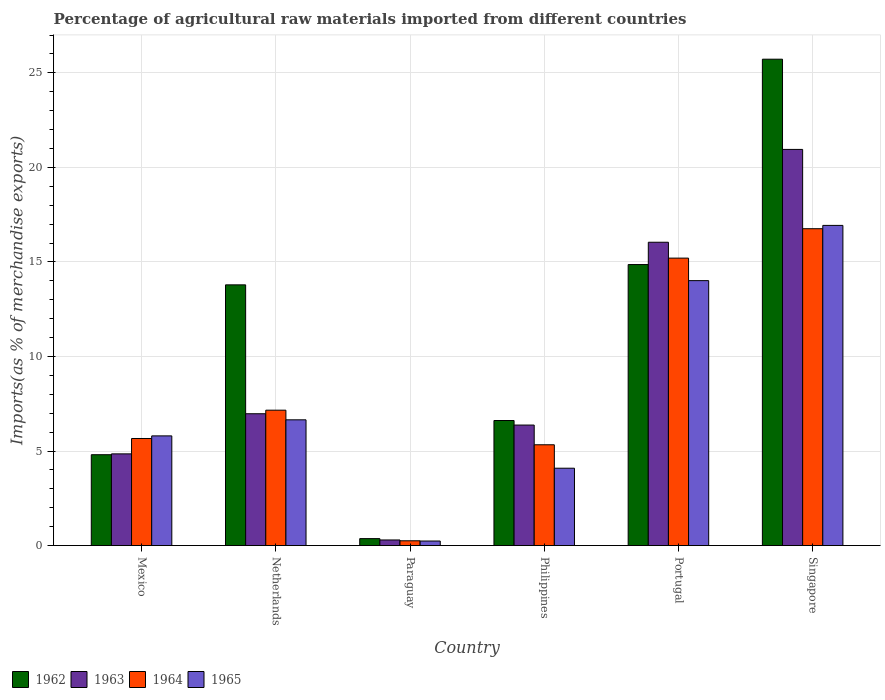How many groups of bars are there?
Make the answer very short. 6. Are the number of bars per tick equal to the number of legend labels?
Offer a terse response. Yes. Are the number of bars on each tick of the X-axis equal?
Your response must be concise. Yes. In how many cases, is the number of bars for a given country not equal to the number of legend labels?
Keep it short and to the point. 0. What is the percentage of imports to different countries in 1962 in Netherlands?
Give a very brief answer. 13.79. Across all countries, what is the maximum percentage of imports to different countries in 1965?
Make the answer very short. 16.93. Across all countries, what is the minimum percentage of imports to different countries in 1962?
Provide a short and direct response. 0.37. In which country was the percentage of imports to different countries in 1963 maximum?
Make the answer very short. Singapore. In which country was the percentage of imports to different countries in 1962 minimum?
Provide a short and direct response. Paraguay. What is the total percentage of imports to different countries in 1963 in the graph?
Your answer should be very brief. 55.49. What is the difference between the percentage of imports to different countries in 1964 in Philippines and that in Portugal?
Your answer should be compact. -9.87. What is the difference between the percentage of imports to different countries in 1963 in Netherlands and the percentage of imports to different countries in 1964 in Paraguay?
Offer a terse response. 6.72. What is the average percentage of imports to different countries in 1964 per country?
Your answer should be very brief. 8.4. What is the difference between the percentage of imports to different countries of/in 1962 and percentage of imports to different countries of/in 1963 in Portugal?
Give a very brief answer. -1.18. What is the ratio of the percentage of imports to different countries in 1963 in Netherlands to that in Philippines?
Your answer should be compact. 1.09. Is the percentage of imports to different countries in 1965 in Netherlands less than that in Paraguay?
Keep it short and to the point. No. Is the difference between the percentage of imports to different countries in 1962 in Netherlands and Paraguay greater than the difference between the percentage of imports to different countries in 1963 in Netherlands and Paraguay?
Your answer should be very brief. Yes. What is the difference between the highest and the second highest percentage of imports to different countries in 1964?
Make the answer very short. 9.6. What is the difference between the highest and the lowest percentage of imports to different countries in 1965?
Offer a very short reply. 16.69. Is the sum of the percentage of imports to different countries in 1962 in Mexico and Philippines greater than the maximum percentage of imports to different countries in 1964 across all countries?
Make the answer very short. No. What does the 3rd bar from the left in Paraguay represents?
Offer a terse response. 1964. Is it the case that in every country, the sum of the percentage of imports to different countries in 1963 and percentage of imports to different countries in 1964 is greater than the percentage of imports to different countries in 1965?
Keep it short and to the point. Yes. How many bars are there?
Make the answer very short. 24. Are all the bars in the graph horizontal?
Provide a succinct answer. No. Does the graph contain grids?
Your answer should be very brief. Yes. How many legend labels are there?
Provide a succinct answer. 4. What is the title of the graph?
Keep it short and to the point. Percentage of agricultural raw materials imported from different countries. Does "1991" appear as one of the legend labels in the graph?
Give a very brief answer. No. What is the label or title of the X-axis?
Ensure brevity in your answer.  Country. What is the label or title of the Y-axis?
Your answer should be compact. Imports(as % of merchandise exports). What is the Imports(as % of merchandise exports) in 1962 in Mexico?
Ensure brevity in your answer.  4.81. What is the Imports(as % of merchandise exports) in 1963 in Mexico?
Make the answer very short. 4.85. What is the Imports(as % of merchandise exports) of 1964 in Mexico?
Give a very brief answer. 5.66. What is the Imports(as % of merchandise exports) in 1965 in Mexico?
Give a very brief answer. 5.8. What is the Imports(as % of merchandise exports) in 1962 in Netherlands?
Keep it short and to the point. 13.79. What is the Imports(as % of merchandise exports) in 1963 in Netherlands?
Offer a terse response. 6.97. What is the Imports(as % of merchandise exports) in 1964 in Netherlands?
Keep it short and to the point. 7.16. What is the Imports(as % of merchandise exports) of 1965 in Netherlands?
Provide a succinct answer. 6.65. What is the Imports(as % of merchandise exports) of 1962 in Paraguay?
Offer a terse response. 0.37. What is the Imports(as % of merchandise exports) of 1963 in Paraguay?
Your response must be concise. 0.3. What is the Imports(as % of merchandise exports) of 1964 in Paraguay?
Your answer should be compact. 0.25. What is the Imports(as % of merchandise exports) in 1965 in Paraguay?
Offer a terse response. 0.24. What is the Imports(as % of merchandise exports) in 1962 in Philippines?
Offer a terse response. 6.61. What is the Imports(as % of merchandise exports) in 1963 in Philippines?
Ensure brevity in your answer.  6.37. What is the Imports(as % of merchandise exports) in 1964 in Philippines?
Your answer should be compact. 5.33. What is the Imports(as % of merchandise exports) in 1965 in Philippines?
Provide a short and direct response. 4.09. What is the Imports(as % of merchandise exports) in 1962 in Portugal?
Make the answer very short. 14.86. What is the Imports(as % of merchandise exports) of 1963 in Portugal?
Provide a succinct answer. 16.04. What is the Imports(as % of merchandise exports) of 1964 in Portugal?
Offer a terse response. 15.2. What is the Imports(as % of merchandise exports) of 1965 in Portugal?
Your answer should be compact. 14.01. What is the Imports(as % of merchandise exports) of 1962 in Singapore?
Your response must be concise. 25.73. What is the Imports(as % of merchandise exports) of 1963 in Singapore?
Offer a very short reply. 20.95. What is the Imports(as % of merchandise exports) in 1964 in Singapore?
Your answer should be compact. 16.76. What is the Imports(as % of merchandise exports) in 1965 in Singapore?
Make the answer very short. 16.93. Across all countries, what is the maximum Imports(as % of merchandise exports) in 1962?
Ensure brevity in your answer.  25.73. Across all countries, what is the maximum Imports(as % of merchandise exports) in 1963?
Provide a succinct answer. 20.95. Across all countries, what is the maximum Imports(as % of merchandise exports) of 1964?
Offer a terse response. 16.76. Across all countries, what is the maximum Imports(as % of merchandise exports) in 1965?
Your answer should be compact. 16.93. Across all countries, what is the minimum Imports(as % of merchandise exports) in 1962?
Your response must be concise. 0.37. Across all countries, what is the minimum Imports(as % of merchandise exports) in 1963?
Provide a succinct answer. 0.3. Across all countries, what is the minimum Imports(as % of merchandise exports) of 1964?
Offer a terse response. 0.25. Across all countries, what is the minimum Imports(as % of merchandise exports) of 1965?
Your response must be concise. 0.24. What is the total Imports(as % of merchandise exports) in 1962 in the graph?
Your response must be concise. 66.17. What is the total Imports(as % of merchandise exports) of 1963 in the graph?
Make the answer very short. 55.49. What is the total Imports(as % of merchandise exports) of 1964 in the graph?
Ensure brevity in your answer.  50.37. What is the total Imports(as % of merchandise exports) in 1965 in the graph?
Make the answer very short. 47.73. What is the difference between the Imports(as % of merchandise exports) of 1962 in Mexico and that in Netherlands?
Give a very brief answer. -8.98. What is the difference between the Imports(as % of merchandise exports) in 1963 in Mexico and that in Netherlands?
Give a very brief answer. -2.12. What is the difference between the Imports(as % of merchandise exports) of 1964 in Mexico and that in Netherlands?
Provide a succinct answer. -1.5. What is the difference between the Imports(as % of merchandise exports) of 1965 in Mexico and that in Netherlands?
Give a very brief answer. -0.85. What is the difference between the Imports(as % of merchandise exports) in 1962 in Mexico and that in Paraguay?
Your response must be concise. 4.44. What is the difference between the Imports(as % of merchandise exports) in 1963 in Mexico and that in Paraguay?
Make the answer very short. 4.55. What is the difference between the Imports(as % of merchandise exports) in 1964 in Mexico and that in Paraguay?
Your answer should be compact. 5.41. What is the difference between the Imports(as % of merchandise exports) of 1965 in Mexico and that in Paraguay?
Keep it short and to the point. 5.56. What is the difference between the Imports(as % of merchandise exports) in 1962 in Mexico and that in Philippines?
Keep it short and to the point. -1.81. What is the difference between the Imports(as % of merchandise exports) of 1963 in Mexico and that in Philippines?
Offer a very short reply. -1.52. What is the difference between the Imports(as % of merchandise exports) in 1964 in Mexico and that in Philippines?
Keep it short and to the point. 0.33. What is the difference between the Imports(as % of merchandise exports) in 1965 in Mexico and that in Philippines?
Your answer should be compact. 1.71. What is the difference between the Imports(as % of merchandise exports) of 1962 in Mexico and that in Portugal?
Your answer should be very brief. -10.06. What is the difference between the Imports(as % of merchandise exports) in 1963 in Mexico and that in Portugal?
Offer a very short reply. -11.19. What is the difference between the Imports(as % of merchandise exports) of 1964 in Mexico and that in Portugal?
Make the answer very short. -9.54. What is the difference between the Imports(as % of merchandise exports) in 1965 in Mexico and that in Portugal?
Provide a succinct answer. -8.21. What is the difference between the Imports(as % of merchandise exports) in 1962 in Mexico and that in Singapore?
Your answer should be compact. -20.92. What is the difference between the Imports(as % of merchandise exports) in 1963 in Mexico and that in Singapore?
Your answer should be compact. -16.1. What is the difference between the Imports(as % of merchandise exports) in 1964 in Mexico and that in Singapore?
Keep it short and to the point. -11.1. What is the difference between the Imports(as % of merchandise exports) in 1965 in Mexico and that in Singapore?
Provide a short and direct response. -11.13. What is the difference between the Imports(as % of merchandise exports) of 1962 in Netherlands and that in Paraguay?
Make the answer very short. 13.42. What is the difference between the Imports(as % of merchandise exports) in 1963 in Netherlands and that in Paraguay?
Your response must be concise. 6.68. What is the difference between the Imports(as % of merchandise exports) of 1964 in Netherlands and that in Paraguay?
Provide a succinct answer. 6.91. What is the difference between the Imports(as % of merchandise exports) of 1965 in Netherlands and that in Paraguay?
Offer a terse response. 6.41. What is the difference between the Imports(as % of merchandise exports) in 1962 in Netherlands and that in Philippines?
Provide a succinct answer. 7.18. What is the difference between the Imports(as % of merchandise exports) of 1963 in Netherlands and that in Philippines?
Provide a succinct answer. 0.6. What is the difference between the Imports(as % of merchandise exports) of 1964 in Netherlands and that in Philippines?
Offer a terse response. 1.83. What is the difference between the Imports(as % of merchandise exports) of 1965 in Netherlands and that in Philippines?
Give a very brief answer. 2.56. What is the difference between the Imports(as % of merchandise exports) of 1962 in Netherlands and that in Portugal?
Keep it short and to the point. -1.07. What is the difference between the Imports(as % of merchandise exports) of 1963 in Netherlands and that in Portugal?
Offer a very short reply. -9.07. What is the difference between the Imports(as % of merchandise exports) of 1964 in Netherlands and that in Portugal?
Offer a very short reply. -8.04. What is the difference between the Imports(as % of merchandise exports) in 1965 in Netherlands and that in Portugal?
Your answer should be very brief. -7.36. What is the difference between the Imports(as % of merchandise exports) of 1962 in Netherlands and that in Singapore?
Ensure brevity in your answer.  -11.94. What is the difference between the Imports(as % of merchandise exports) of 1963 in Netherlands and that in Singapore?
Offer a very short reply. -13.98. What is the difference between the Imports(as % of merchandise exports) of 1964 in Netherlands and that in Singapore?
Offer a terse response. -9.6. What is the difference between the Imports(as % of merchandise exports) of 1965 in Netherlands and that in Singapore?
Offer a very short reply. -10.28. What is the difference between the Imports(as % of merchandise exports) of 1962 in Paraguay and that in Philippines?
Your answer should be compact. -6.25. What is the difference between the Imports(as % of merchandise exports) in 1963 in Paraguay and that in Philippines?
Provide a succinct answer. -6.08. What is the difference between the Imports(as % of merchandise exports) in 1964 in Paraguay and that in Philippines?
Provide a short and direct response. -5.08. What is the difference between the Imports(as % of merchandise exports) in 1965 in Paraguay and that in Philippines?
Offer a terse response. -3.85. What is the difference between the Imports(as % of merchandise exports) of 1962 in Paraguay and that in Portugal?
Provide a succinct answer. -14.5. What is the difference between the Imports(as % of merchandise exports) in 1963 in Paraguay and that in Portugal?
Your answer should be very brief. -15.75. What is the difference between the Imports(as % of merchandise exports) in 1964 in Paraguay and that in Portugal?
Give a very brief answer. -14.95. What is the difference between the Imports(as % of merchandise exports) of 1965 in Paraguay and that in Portugal?
Your answer should be compact. -13.77. What is the difference between the Imports(as % of merchandise exports) in 1962 in Paraguay and that in Singapore?
Ensure brevity in your answer.  -25.36. What is the difference between the Imports(as % of merchandise exports) in 1963 in Paraguay and that in Singapore?
Give a very brief answer. -20.66. What is the difference between the Imports(as % of merchandise exports) of 1964 in Paraguay and that in Singapore?
Your answer should be compact. -16.51. What is the difference between the Imports(as % of merchandise exports) of 1965 in Paraguay and that in Singapore?
Your answer should be compact. -16.69. What is the difference between the Imports(as % of merchandise exports) in 1962 in Philippines and that in Portugal?
Your answer should be very brief. -8.25. What is the difference between the Imports(as % of merchandise exports) in 1963 in Philippines and that in Portugal?
Your answer should be very brief. -9.67. What is the difference between the Imports(as % of merchandise exports) in 1964 in Philippines and that in Portugal?
Ensure brevity in your answer.  -9.87. What is the difference between the Imports(as % of merchandise exports) in 1965 in Philippines and that in Portugal?
Keep it short and to the point. -9.92. What is the difference between the Imports(as % of merchandise exports) of 1962 in Philippines and that in Singapore?
Your answer should be compact. -19.11. What is the difference between the Imports(as % of merchandise exports) of 1963 in Philippines and that in Singapore?
Your answer should be very brief. -14.58. What is the difference between the Imports(as % of merchandise exports) of 1964 in Philippines and that in Singapore?
Ensure brevity in your answer.  -11.43. What is the difference between the Imports(as % of merchandise exports) of 1965 in Philippines and that in Singapore?
Ensure brevity in your answer.  -12.84. What is the difference between the Imports(as % of merchandise exports) of 1962 in Portugal and that in Singapore?
Make the answer very short. -10.86. What is the difference between the Imports(as % of merchandise exports) of 1963 in Portugal and that in Singapore?
Ensure brevity in your answer.  -4.91. What is the difference between the Imports(as % of merchandise exports) of 1964 in Portugal and that in Singapore?
Provide a short and direct response. -1.55. What is the difference between the Imports(as % of merchandise exports) of 1965 in Portugal and that in Singapore?
Your response must be concise. -2.92. What is the difference between the Imports(as % of merchandise exports) of 1962 in Mexico and the Imports(as % of merchandise exports) of 1963 in Netherlands?
Give a very brief answer. -2.17. What is the difference between the Imports(as % of merchandise exports) in 1962 in Mexico and the Imports(as % of merchandise exports) in 1964 in Netherlands?
Make the answer very short. -2.36. What is the difference between the Imports(as % of merchandise exports) in 1962 in Mexico and the Imports(as % of merchandise exports) in 1965 in Netherlands?
Your answer should be compact. -1.85. What is the difference between the Imports(as % of merchandise exports) of 1963 in Mexico and the Imports(as % of merchandise exports) of 1964 in Netherlands?
Ensure brevity in your answer.  -2.31. What is the difference between the Imports(as % of merchandise exports) in 1963 in Mexico and the Imports(as % of merchandise exports) in 1965 in Netherlands?
Give a very brief answer. -1.8. What is the difference between the Imports(as % of merchandise exports) of 1964 in Mexico and the Imports(as % of merchandise exports) of 1965 in Netherlands?
Ensure brevity in your answer.  -0.99. What is the difference between the Imports(as % of merchandise exports) of 1962 in Mexico and the Imports(as % of merchandise exports) of 1963 in Paraguay?
Provide a short and direct response. 4.51. What is the difference between the Imports(as % of merchandise exports) of 1962 in Mexico and the Imports(as % of merchandise exports) of 1964 in Paraguay?
Keep it short and to the point. 4.55. What is the difference between the Imports(as % of merchandise exports) in 1962 in Mexico and the Imports(as % of merchandise exports) in 1965 in Paraguay?
Ensure brevity in your answer.  4.57. What is the difference between the Imports(as % of merchandise exports) in 1963 in Mexico and the Imports(as % of merchandise exports) in 1964 in Paraguay?
Offer a terse response. 4.6. What is the difference between the Imports(as % of merchandise exports) of 1963 in Mexico and the Imports(as % of merchandise exports) of 1965 in Paraguay?
Give a very brief answer. 4.61. What is the difference between the Imports(as % of merchandise exports) of 1964 in Mexico and the Imports(as % of merchandise exports) of 1965 in Paraguay?
Your answer should be very brief. 5.42. What is the difference between the Imports(as % of merchandise exports) in 1962 in Mexico and the Imports(as % of merchandise exports) in 1963 in Philippines?
Your answer should be very brief. -1.57. What is the difference between the Imports(as % of merchandise exports) of 1962 in Mexico and the Imports(as % of merchandise exports) of 1964 in Philippines?
Offer a terse response. -0.53. What is the difference between the Imports(as % of merchandise exports) of 1962 in Mexico and the Imports(as % of merchandise exports) of 1965 in Philippines?
Offer a very short reply. 0.71. What is the difference between the Imports(as % of merchandise exports) in 1963 in Mexico and the Imports(as % of merchandise exports) in 1964 in Philippines?
Your answer should be compact. -0.48. What is the difference between the Imports(as % of merchandise exports) in 1963 in Mexico and the Imports(as % of merchandise exports) in 1965 in Philippines?
Provide a succinct answer. 0.76. What is the difference between the Imports(as % of merchandise exports) of 1964 in Mexico and the Imports(as % of merchandise exports) of 1965 in Philippines?
Keep it short and to the point. 1.57. What is the difference between the Imports(as % of merchandise exports) in 1962 in Mexico and the Imports(as % of merchandise exports) in 1963 in Portugal?
Your answer should be very brief. -11.24. What is the difference between the Imports(as % of merchandise exports) of 1962 in Mexico and the Imports(as % of merchandise exports) of 1964 in Portugal?
Give a very brief answer. -10.4. What is the difference between the Imports(as % of merchandise exports) of 1962 in Mexico and the Imports(as % of merchandise exports) of 1965 in Portugal?
Give a very brief answer. -9.21. What is the difference between the Imports(as % of merchandise exports) of 1963 in Mexico and the Imports(as % of merchandise exports) of 1964 in Portugal?
Offer a terse response. -10.35. What is the difference between the Imports(as % of merchandise exports) of 1963 in Mexico and the Imports(as % of merchandise exports) of 1965 in Portugal?
Offer a very short reply. -9.16. What is the difference between the Imports(as % of merchandise exports) of 1964 in Mexico and the Imports(as % of merchandise exports) of 1965 in Portugal?
Give a very brief answer. -8.35. What is the difference between the Imports(as % of merchandise exports) of 1962 in Mexico and the Imports(as % of merchandise exports) of 1963 in Singapore?
Offer a terse response. -16.15. What is the difference between the Imports(as % of merchandise exports) in 1962 in Mexico and the Imports(as % of merchandise exports) in 1964 in Singapore?
Provide a short and direct response. -11.95. What is the difference between the Imports(as % of merchandise exports) of 1962 in Mexico and the Imports(as % of merchandise exports) of 1965 in Singapore?
Offer a terse response. -12.13. What is the difference between the Imports(as % of merchandise exports) of 1963 in Mexico and the Imports(as % of merchandise exports) of 1964 in Singapore?
Ensure brevity in your answer.  -11.91. What is the difference between the Imports(as % of merchandise exports) of 1963 in Mexico and the Imports(as % of merchandise exports) of 1965 in Singapore?
Provide a short and direct response. -12.08. What is the difference between the Imports(as % of merchandise exports) in 1964 in Mexico and the Imports(as % of merchandise exports) in 1965 in Singapore?
Keep it short and to the point. -11.27. What is the difference between the Imports(as % of merchandise exports) in 1962 in Netherlands and the Imports(as % of merchandise exports) in 1963 in Paraguay?
Ensure brevity in your answer.  13.49. What is the difference between the Imports(as % of merchandise exports) in 1962 in Netherlands and the Imports(as % of merchandise exports) in 1964 in Paraguay?
Give a very brief answer. 13.54. What is the difference between the Imports(as % of merchandise exports) of 1962 in Netherlands and the Imports(as % of merchandise exports) of 1965 in Paraguay?
Provide a succinct answer. 13.55. What is the difference between the Imports(as % of merchandise exports) in 1963 in Netherlands and the Imports(as % of merchandise exports) in 1964 in Paraguay?
Provide a short and direct response. 6.72. What is the difference between the Imports(as % of merchandise exports) of 1963 in Netherlands and the Imports(as % of merchandise exports) of 1965 in Paraguay?
Offer a very short reply. 6.73. What is the difference between the Imports(as % of merchandise exports) of 1964 in Netherlands and the Imports(as % of merchandise exports) of 1965 in Paraguay?
Ensure brevity in your answer.  6.92. What is the difference between the Imports(as % of merchandise exports) of 1962 in Netherlands and the Imports(as % of merchandise exports) of 1963 in Philippines?
Ensure brevity in your answer.  7.42. What is the difference between the Imports(as % of merchandise exports) in 1962 in Netherlands and the Imports(as % of merchandise exports) in 1964 in Philippines?
Offer a very short reply. 8.46. What is the difference between the Imports(as % of merchandise exports) of 1962 in Netherlands and the Imports(as % of merchandise exports) of 1965 in Philippines?
Provide a succinct answer. 9.7. What is the difference between the Imports(as % of merchandise exports) in 1963 in Netherlands and the Imports(as % of merchandise exports) in 1964 in Philippines?
Keep it short and to the point. 1.64. What is the difference between the Imports(as % of merchandise exports) of 1963 in Netherlands and the Imports(as % of merchandise exports) of 1965 in Philippines?
Keep it short and to the point. 2.88. What is the difference between the Imports(as % of merchandise exports) of 1964 in Netherlands and the Imports(as % of merchandise exports) of 1965 in Philippines?
Provide a succinct answer. 3.07. What is the difference between the Imports(as % of merchandise exports) in 1962 in Netherlands and the Imports(as % of merchandise exports) in 1963 in Portugal?
Provide a succinct answer. -2.25. What is the difference between the Imports(as % of merchandise exports) in 1962 in Netherlands and the Imports(as % of merchandise exports) in 1964 in Portugal?
Offer a very short reply. -1.41. What is the difference between the Imports(as % of merchandise exports) in 1962 in Netherlands and the Imports(as % of merchandise exports) in 1965 in Portugal?
Your response must be concise. -0.22. What is the difference between the Imports(as % of merchandise exports) of 1963 in Netherlands and the Imports(as % of merchandise exports) of 1964 in Portugal?
Offer a terse response. -8.23. What is the difference between the Imports(as % of merchandise exports) in 1963 in Netherlands and the Imports(as % of merchandise exports) in 1965 in Portugal?
Offer a terse response. -7.04. What is the difference between the Imports(as % of merchandise exports) in 1964 in Netherlands and the Imports(as % of merchandise exports) in 1965 in Portugal?
Your answer should be very brief. -6.85. What is the difference between the Imports(as % of merchandise exports) of 1962 in Netherlands and the Imports(as % of merchandise exports) of 1963 in Singapore?
Keep it short and to the point. -7.16. What is the difference between the Imports(as % of merchandise exports) of 1962 in Netherlands and the Imports(as % of merchandise exports) of 1964 in Singapore?
Offer a terse response. -2.97. What is the difference between the Imports(as % of merchandise exports) in 1962 in Netherlands and the Imports(as % of merchandise exports) in 1965 in Singapore?
Your response must be concise. -3.14. What is the difference between the Imports(as % of merchandise exports) of 1963 in Netherlands and the Imports(as % of merchandise exports) of 1964 in Singapore?
Your answer should be compact. -9.79. What is the difference between the Imports(as % of merchandise exports) of 1963 in Netherlands and the Imports(as % of merchandise exports) of 1965 in Singapore?
Offer a terse response. -9.96. What is the difference between the Imports(as % of merchandise exports) in 1964 in Netherlands and the Imports(as % of merchandise exports) in 1965 in Singapore?
Provide a short and direct response. -9.77. What is the difference between the Imports(as % of merchandise exports) of 1962 in Paraguay and the Imports(as % of merchandise exports) of 1963 in Philippines?
Offer a very short reply. -6.01. What is the difference between the Imports(as % of merchandise exports) in 1962 in Paraguay and the Imports(as % of merchandise exports) in 1964 in Philippines?
Provide a short and direct response. -4.96. What is the difference between the Imports(as % of merchandise exports) of 1962 in Paraguay and the Imports(as % of merchandise exports) of 1965 in Philippines?
Offer a very short reply. -3.72. What is the difference between the Imports(as % of merchandise exports) in 1963 in Paraguay and the Imports(as % of merchandise exports) in 1964 in Philippines?
Ensure brevity in your answer.  -5.04. What is the difference between the Imports(as % of merchandise exports) in 1963 in Paraguay and the Imports(as % of merchandise exports) in 1965 in Philippines?
Offer a very short reply. -3.8. What is the difference between the Imports(as % of merchandise exports) in 1964 in Paraguay and the Imports(as % of merchandise exports) in 1965 in Philippines?
Make the answer very short. -3.84. What is the difference between the Imports(as % of merchandise exports) of 1962 in Paraguay and the Imports(as % of merchandise exports) of 1963 in Portugal?
Make the answer very short. -15.68. What is the difference between the Imports(as % of merchandise exports) of 1962 in Paraguay and the Imports(as % of merchandise exports) of 1964 in Portugal?
Keep it short and to the point. -14.84. What is the difference between the Imports(as % of merchandise exports) in 1962 in Paraguay and the Imports(as % of merchandise exports) in 1965 in Portugal?
Your answer should be very brief. -13.65. What is the difference between the Imports(as % of merchandise exports) in 1963 in Paraguay and the Imports(as % of merchandise exports) in 1964 in Portugal?
Your response must be concise. -14.91. What is the difference between the Imports(as % of merchandise exports) in 1963 in Paraguay and the Imports(as % of merchandise exports) in 1965 in Portugal?
Ensure brevity in your answer.  -13.72. What is the difference between the Imports(as % of merchandise exports) of 1964 in Paraguay and the Imports(as % of merchandise exports) of 1965 in Portugal?
Make the answer very short. -13.76. What is the difference between the Imports(as % of merchandise exports) in 1962 in Paraguay and the Imports(as % of merchandise exports) in 1963 in Singapore?
Make the answer very short. -20.59. What is the difference between the Imports(as % of merchandise exports) in 1962 in Paraguay and the Imports(as % of merchandise exports) in 1964 in Singapore?
Offer a terse response. -16.39. What is the difference between the Imports(as % of merchandise exports) of 1962 in Paraguay and the Imports(as % of merchandise exports) of 1965 in Singapore?
Your answer should be compact. -16.57. What is the difference between the Imports(as % of merchandise exports) in 1963 in Paraguay and the Imports(as % of merchandise exports) in 1964 in Singapore?
Make the answer very short. -16.46. What is the difference between the Imports(as % of merchandise exports) in 1963 in Paraguay and the Imports(as % of merchandise exports) in 1965 in Singapore?
Provide a short and direct response. -16.64. What is the difference between the Imports(as % of merchandise exports) in 1964 in Paraguay and the Imports(as % of merchandise exports) in 1965 in Singapore?
Offer a very short reply. -16.68. What is the difference between the Imports(as % of merchandise exports) in 1962 in Philippines and the Imports(as % of merchandise exports) in 1963 in Portugal?
Offer a very short reply. -9.43. What is the difference between the Imports(as % of merchandise exports) of 1962 in Philippines and the Imports(as % of merchandise exports) of 1964 in Portugal?
Make the answer very short. -8.59. What is the difference between the Imports(as % of merchandise exports) of 1962 in Philippines and the Imports(as % of merchandise exports) of 1965 in Portugal?
Ensure brevity in your answer.  -7.4. What is the difference between the Imports(as % of merchandise exports) of 1963 in Philippines and the Imports(as % of merchandise exports) of 1964 in Portugal?
Provide a short and direct response. -8.83. What is the difference between the Imports(as % of merchandise exports) of 1963 in Philippines and the Imports(as % of merchandise exports) of 1965 in Portugal?
Your answer should be very brief. -7.64. What is the difference between the Imports(as % of merchandise exports) in 1964 in Philippines and the Imports(as % of merchandise exports) in 1965 in Portugal?
Your response must be concise. -8.68. What is the difference between the Imports(as % of merchandise exports) in 1962 in Philippines and the Imports(as % of merchandise exports) in 1963 in Singapore?
Your response must be concise. -14.34. What is the difference between the Imports(as % of merchandise exports) of 1962 in Philippines and the Imports(as % of merchandise exports) of 1964 in Singapore?
Offer a terse response. -10.14. What is the difference between the Imports(as % of merchandise exports) in 1962 in Philippines and the Imports(as % of merchandise exports) in 1965 in Singapore?
Your response must be concise. -10.32. What is the difference between the Imports(as % of merchandise exports) of 1963 in Philippines and the Imports(as % of merchandise exports) of 1964 in Singapore?
Offer a terse response. -10.39. What is the difference between the Imports(as % of merchandise exports) in 1963 in Philippines and the Imports(as % of merchandise exports) in 1965 in Singapore?
Provide a succinct answer. -10.56. What is the difference between the Imports(as % of merchandise exports) of 1964 in Philippines and the Imports(as % of merchandise exports) of 1965 in Singapore?
Make the answer very short. -11.6. What is the difference between the Imports(as % of merchandise exports) of 1962 in Portugal and the Imports(as % of merchandise exports) of 1963 in Singapore?
Offer a very short reply. -6.09. What is the difference between the Imports(as % of merchandise exports) in 1962 in Portugal and the Imports(as % of merchandise exports) in 1964 in Singapore?
Provide a succinct answer. -1.9. What is the difference between the Imports(as % of merchandise exports) of 1962 in Portugal and the Imports(as % of merchandise exports) of 1965 in Singapore?
Provide a succinct answer. -2.07. What is the difference between the Imports(as % of merchandise exports) in 1963 in Portugal and the Imports(as % of merchandise exports) in 1964 in Singapore?
Offer a terse response. -0.72. What is the difference between the Imports(as % of merchandise exports) in 1963 in Portugal and the Imports(as % of merchandise exports) in 1965 in Singapore?
Offer a very short reply. -0.89. What is the difference between the Imports(as % of merchandise exports) of 1964 in Portugal and the Imports(as % of merchandise exports) of 1965 in Singapore?
Keep it short and to the point. -1.73. What is the average Imports(as % of merchandise exports) in 1962 per country?
Your answer should be compact. 11.03. What is the average Imports(as % of merchandise exports) of 1963 per country?
Provide a short and direct response. 9.25. What is the average Imports(as % of merchandise exports) in 1964 per country?
Provide a succinct answer. 8.4. What is the average Imports(as % of merchandise exports) of 1965 per country?
Offer a very short reply. 7.96. What is the difference between the Imports(as % of merchandise exports) of 1962 and Imports(as % of merchandise exports) of 1963 in Mexico?
Your answer should be compact. -0.04. What is the difference between the Imports(as % of merchandise exports) of 1962 and Imports(as % of merchandise exports) of 1964 in Mexico?
Offer a terse response. -0.86. What is the difference between the Imports(as % of merchandise exports) in 1962 and Imports(as % of merchandise exports) in 1965 in Mexico?
Give a very brief answer. -1. What is the difference between the Imports(as % of merchandise exports) in 1963 and Imports(as % of merchandise exports) in 1964 in Mexico?
Offer a very short reply. -0.81. What is the difference between the Imports(as % of merchandise exports) in 1963 and Imports(as % of merchandise exports) in 1965 in Mexico?
Your response must be concise. -0.95. What is the difference between the Imports(as % of merchandise exports) in 1964 and Imports(as % of merchandise exports) in 1965 in Mexico?
Provide a succinct answer. -0.14. What is the difference between the Imports(as % of merchandise exports) of 1962 and Imports(as % of merchandise exports) of 1963 in Netherlands?
Provide a short and direct response. 6.82. What is the difference between the Imports(as % of merchandise exports) of 1962 and Imports(as % of merchandise exports) of 1964 in Netherlands?
Provide a succinct answer. 6.63. What is the difference between the Imports(as % of merchandise exports) in 1962 and Imports(as % of merchandise exports) in 1965 in Netherlands?
Ensure brevity in your answer.  7.14. What is the difference between the Imports(as % of merchandise exports) of 1963 and Imports(as % of merchandise exports) of 1964 in Netherlands?
Make the answer very short. -0.19. What is the difference between the Imports(as % of merchandise exports) in 1963 and Imports(as % of merchandise exports) in 1965 in Netherlands?
Offer a terse response. 0.32. What is the difference between the Imports(as % of merchandise exports) of 1964 and Imports(as % of merchandise exports) of 1965 in Netherlands?
Offer a terse response. 0.51. What is the difference between the Imports(as % of merchandise exports) of 1962 and Imports(as % of merchandise exports) of 1963 in Paraguay?
Give a very brief answer. 0.07. What is the difference between the Imports(as % of merchandise exports) of 1962 and Imports(as % of merchandise exports) of 1964 in Paraguay?
Offer a terse response. 0.11. What is the difference between the Imports(as % of merchandise exports) of 1962 and Imports(as % of merchandise exports) of 1965 in Paraguay?
Provide a succinct answer. 0.13. What is the difference between the Imports(as % of merchandise exports) in 1963 and Imports(as % of merchandise exports) in 1964 in Paraguay?
Your answer should be compact. 0.04. What is the difference between the Imports(as % of merchandise exports) in 1963 and Imports(as % of merchandise exports) in 1965 in Paraguay?
Ensure brevity in your answer.  0.06. What is the difference between the Imports(as % of merchandise exports) of 1964 and Imports(as % of merchandise exports) of 1965 in Paraguay?
Ensure brevity in your answer.  0.01. What is the difference between the Imports(as % of merchandise exports) of 1962 and Imports(as % of merchandise exports) of 1963 in Philippines?
Your response must be concise. 0.24. What is the difference between the Imports(as % of merchandise exports) in 1962 and Imports(as % of merchandise exports) in 1964 in Philippines?
Provide a succinct answer. 1.28. What is the difference between the Imports(as % of merchandise exports) of 1962 and Imports(as % of merchandise exports) of 1965 in Philippines?
Your response must be concise. 2.52. What is the difference between the Imports(as % of merchandise exports) of 1963 and Imports(as % of merchandise exports) of 1964 in Philippines?
Your answer should be very brief. 1.04. What is the difference between the Imports(as % of merchandise exports) of 1963 and Imports(as % of merchandise exports) of 1965 in Philippines?
Give a very brief answer. 2.28. What is the difference between the Imports(as % of merchandise exports) of 1964 and Imports(as % of merchandise exports) of 1965 in Philippines?
Ensure brevity in your answer.  1.24. What is the difference between the Imports(as % of merchandise exports) of 1962 and Imports(as % of merchandise exports) of 1963 in Portugal?
Provide a succinct answer. -1.18. What is the difference between the Imports(as % of merchandise exports) in 1962 and Imports(as % of merchandise exports) in 1964 in Portugal?
Provide a succinct answer. -0.34. What is the difference between the Imports(as % of merchandise exports) in 1962 and Imports(as % of merchandise exports) in 1965 in Portugal?
Your answer should be compact. 0.85. What is the difference between the Imports(as % of merchandise exports) of 1963 and Imports(as % of merchandise exports) of 1964 in Portugal?
Keep it short and to the point. 0.84. What is the difference between the Imports(as % of merchandise exports) of 1963 and Imports(as % of merchandise exports) of 1965 in Portugal?
Your answer should be compact. 2.03. What is the difference between the Imports(as % of merchandise exports) in 1964 and Imports(as % of merchandise exports) in 1965 in Portugal?
Ensure brevity in your answer.  1.19. What is the difference between the Imports(as % of merchandise exports) in 1962 and Imports(as % of merchandise exports) in 1963 in Singapore?
Offer a terse response. 4.77. What is the difference between the Imports(as % of merchandise exports) of 1962 and Imports(as % of merchandise exports) of 1964 in Singapore?
Provide a short and direct response. 8.97. What is the difference between the Imports(as % of merchandise exports) of 1962 and Imports(as % of merchandise exports) of 1965 in Singapore?
Provide a short and direct response. 8.79. What is the difference between the Imports(as % of merchandise exports) in 1963 and Imports(as % of merchandise exports) in 1964 in Singapore?
Provide a succinct answer. 4.19. What is the difference between the Imports(as % of merchandise exports) of 1963 and Imports(as % of merchandise exports) of 1965 in Singapore?
Give a very brief answer. 4.02. What is the difference between the Imports(as % of merchandise exports) of 1964 and Imports(as % of merchandise exports) of 1965 in Singapore?
Provide a short and direct response. -0.18. What is the ratio of the Imports(as % of merchandise exports) in 1962 in Mexico to that in Netherlands?
Your answer should be compact. 0.35. What is the ratio of the Imports(as % of merchandise exports) in 1963 in Mexico to that in Netherlands?
Offer a very short reply. 0.7. What is the ratio of the Imports(as % of merchandise exports) of 1964 in Mexico to that in Netherlands?
Your response must be concise. 0.79. What is the ratio of the Imports(as % of merchandise exports) of 1965 in Mexico to that in Netherlands?
Ensure brevity in your answer.  0.87. What is the ratio of the Imports(as % of merchandise exports) of 1962 in Mexico to that in Paraguay?
Your answer should be very brief. 13.08. What is the ratio of the Imports(as % of merchandise exports) in 1963 in Mexico to that in Paraguay?
Keep it short and to the point. 16.38. What is the ratio of the Imports(as % of merchandise exports) of 1964 in Mexico to that in Paraguay?
Provide a succinct answer. 22.4. What is the ratio of the Imports(as % of merchandise exports) in 1965 in Mexico to that in Paraguay?
Your response must be concise. 24.12. What is the ratio of the Imports(as % of merchandise exports) of 1962 in Mexico to that in Philippines?
Your answer should be compact. 0.73. What is the ratio of the Imports(as % of merchandise exports) in 1963 in Mexico to that in Philippines?
Ensure brevity in your answer.  0.76. What is the ratio of the Imports(as % of merchandise exports) in 1964 in Mexico to that in Philippines?
Your response must be concise. 1.06. What is the ratio of the Imports(as % of merchandise exports) of 1965 in Mexico to that in Philippines?
Your answer should be compact. 1.42. What is the ratio of the Imports(as % of merchandise exports) in 1962 in Mexico to that in Portugal?
Provide a short and direct response. 0.32. What is the ratio of the Imports(as % of merchandise exports) in 1963 in Mexico to that in Portugal?
Ensure brevity in your answer.  0.3. What is the ratio of the Imports(as % of merchandise exports) of 1964 in Mexico to that in Portugal?
Provide a succinct answer. 0.37. What is the ratio of the Imports(as % of merchandise exports) of 1965 in Mexico to that in Portugal?
Your answer should be very brief. 0.41. What is the ratio of the Imports(as % of merchandise exports) in 1962 in Mexico to that in Singapore?
Provide a succinct answer. 0.19. What is the ratio of the Imports(as % of merchandise exports) in 1963 in Mexico to that in Singapore?
Make the answer very short. 0.23. What is the ratio of the Imports(as % of merchandise exports) in 1964 in Mexico to that in Singapore?
Make the answer very short. 0.34. What is the ratio of the Imports(as % of merchandise exports) in 1965 in Mexico to that in Singapore?
Provide a short and direct response. 0.34. What is the ratio of the Imports(as % of merchandise exports) in 1962 in Netherlands to that in Paraguay?
Give a very brief answer. 37.54. What is the ratio of the Imports(as % of merchandise exports) in 1963 in Netherlands to that in Paraguay?
Provide a succinct answer. 23.54. What is the ratio of the Imports(as % of merchandise exports) in 1964 in Netherlands to that in Paraguay?
Your answer should be very brief. 28.32. What is the ratio of the Imports(as % of merchandise exports) of 1965 in Netherlands to that in Paraguay?
Keep it short and to the point. 27.66. What is the ratio of the Imports(as % of merchandise exports) of 1962 in Netherlands to that in Philippines?
Your response must be concise. 2.08. What is the ratio of the Imports(as % of merchandise exports) of 1963 in Netherlands to that in Philippines?
Make the answer very short. 1.09. What is the ratio of the Imports(as % of merchandise exports) of 1964 in Netherlands to that in Philippines?
Offer a terse response. 1.34. What is the ratio of the Imports(as % of merchandise exports) in 1965 in Netherlands to that in Philippines?
Keep it short and to the point. 1.63. What is the ratio of the Imports(as % of merchandise exports) of 1962 in Netherlands to that in Portugal?
Your answer should be very brief. 0.93. What is the ratio of the Imports(as % of merchandise exports) in 1963 in Netherlands to that in Portugal?
Keep it short and to the point. 0.43. What is the ratio of the Imports(as % of merchandise exports) in 1964 in Netherlands to that in Portugal?
Keep it short and to the point. 0.47. What is the ratio of the Imports(as % of merchandise exports) of 1965 in Netherlands to that in Portugal?
Make the answer very short. 0.47. What is the ratio of the Imports(as % of merchandise exports) of 1962 in Netherlands to that in Singapore?
Provide a succinct answer. 0.54. What is the ratio of the Imports(as % of merchandise exports) in 1963 in Netherlands to that in Singapore?
Your answer should be compact. 0.33. What is the ratio of the Imports(as % of merchandise exports) of 1964 in Netherlands to that in Singapore?
Provide a succinct answer. 0.43. What is the ratio of the Imports(as % of merchandise exports) of 1965 in Netherlands to that in Singapore?
Make the answer very short. 0.39. What is the ratio of the Imports(as % of merchandise exports) of 1962 in Paraguay to that in Philippines?
Your response must be concise. 0.06. What is the ratio of the Imports(as % of merchandise exports) of 1963 in Paraguay to that in Philippines?
Make the answer very short. 0.05. What is the ratio of the Imports(as % of merchandise exports) in 1964 in Paraguay to that in Philippines?
Provide a short and direct response. 0.05. What is the ratio of the Imports(as % of merchandise exports) in 1965 in Paraguay to that in Philippines?
Offer a very short reply. 0.06. What is the ratio of the Imports(as % of merchandise exports) of 1962 in Paraguay to that in Portugal?
Provide a short and direct response. 0.02. What is the ratio of the Imports(as % of merchandise exports) in 1963 in Paraguay to that in Portugal?
Make the answer very short. 0.02. What is the ratio of the Imports(as % of merchandise exports) in 1964 in Paraguay to that in Portugal?
Provide a short and direct response. 0.02. What is the ratio of the Imports(as % of merchandise exports) in 1965 in Paraguay to that in Portugal?
Your response must be concise. 0.02. What is the ratio of the Imports(as % of merchandise exports) of 1962 in Paraguay to that in Singapore?
Ensure brevity in your answer.  0.01. What is the ratio of the Imports(as % of merchandise exports) in 1963 in Paraguay to that in Singapore?
Provide a succinct answer. 0.01. What is the ratio of the Imports(as % of merchandise exports) in 1964 in Paraguay to that in Singapore?
Ensure brevity in your answer.  0.02. What is the ratio of the Imports(as % of merchandise exports) in 1965 in Paraguay to that in Singapore?
Your response must be concise. 0.01. What is the ratio of the Imports(as % of merchandise exports) of 1962 in Philippines to that in Portugal?
Make the answer very short. 0.45. What is the ratio of the Imports(as % of merchandise exports) of 1963 in Philippines to that in Portugal?
Your response must be concise. 0.4. What is the ratio of the Imports(as % of merchandise exports) of 1964 in Philippines to that in Portugal?
Give a very brief answer. 0.35. What is the ratio of the Imports(as % of merchandise exports) in 1965 in Philippines to that in Portugal?
Your answer should be compact. 0.29. What is the ratio of the Imports(as % of merchandise exports) in 1962 in Philippines to that in Singapore?
Offer a terse response. 0.26. What is the ratio of the Imports(as % of merchandise exports) in 1963 in Philippines to that in Singapore?
Provide a succinct answer. 0.3. What is the ratio of the Imports(as % of merchandise exports) of 1964 in Philippines to that in Singapore?
Your answer should be compact. 0.32. What is the ratio of the Imports(as % of merchandise exports) of 1965 in Philippines to that in Singapore?
Offer a terse response. 0.24. What is the ratio of the Imports(as % of merchandise exports) in 1962 in Portugal to that in Singapore?
Your answer should be compact. 0.58. What is the ratio of the Imports(as % of merchandise exports) of 1963 in Portugal to that in Singapore?
Make the answer very short. 0.77. What is the ratio of the Imports(as % of merchandise exports) of 1964 in Portugal to that in Singapore?
Your answer should be very brief. 0.91. What is the ratio of the Imports(as % of merchandise exports) of 1965 in Portugal to that in Singapore?
Provide a short and direct response. 0.83. What is the difference between the highest and the second highest Imports(as % of merchandise exports) of 1962?
Keep it short and to the point. 10.86. What is the difference between the highest and the second highest Imports(as % of merchandise exports) of 1963?
Provide a short and direct response. 4.91. What is the difference between the highest and the second highest Imports(as % of merchandise exports) in 1964?
Keep it short and to the point. 1.55. What is the difference between the highest and the second highest Imports(as % of merchandise exports) of 1965?
Provide a succinct answer. 2.92. What is the difference between the highest and the lowest Imports(as % of merchandise exports) of 1962?
Your answer should be compact. 25.36. What is the difference between the highest and the lowest Imports(as % of merchandise exports) in 1963?
Ensure brevity in your answer.  20.66. What is the difference between the highest and the lowest Imports(as % of merchandise exports) in 1964?
Ensure brevity in your answer.  16.51. What is the difference between the highest and the lowest Imports(as % of merchandise exports) of 1965?
Your response must be concise. 16.69. 